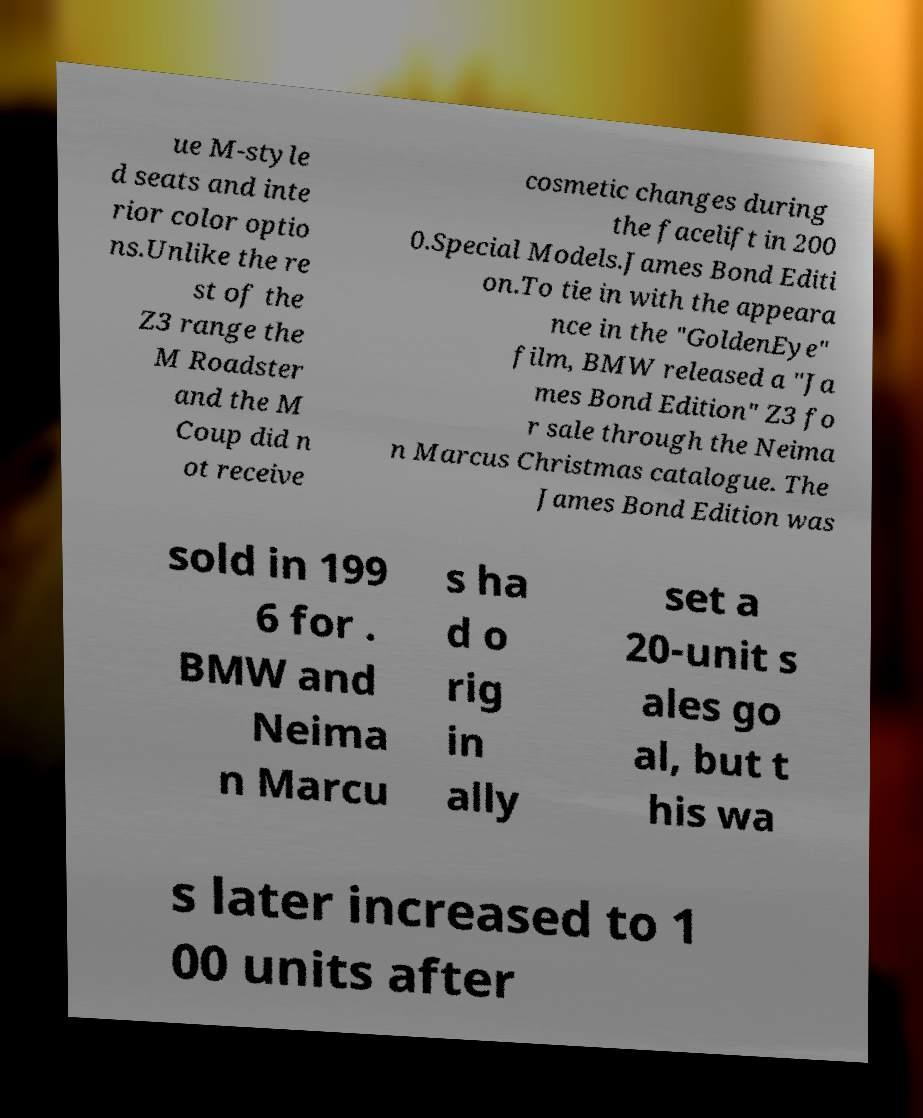I need the written content from this picture converted into text. Can you do that? ue M-style d seats and inte rior color optio ns.Unlike the re st of the Z3 range the M Roadster and the M Coup did n ot receive cosmetic changes during the facelift in 200 0.Special Models.James Bond Editi on.To tie in with the appeara nce in the "GoldenEye" film, BMW released a "Ja mes Bond Edition" Z3 fo r sale through the Neima n Marcus Christmas catalogue. The James Bond Edition was sold in 199 6 for . BMW and Neima n Marcu s ha d o rig in ally set a 20-unit s ales go al, but t his wa s later increased to 1 00 units after 